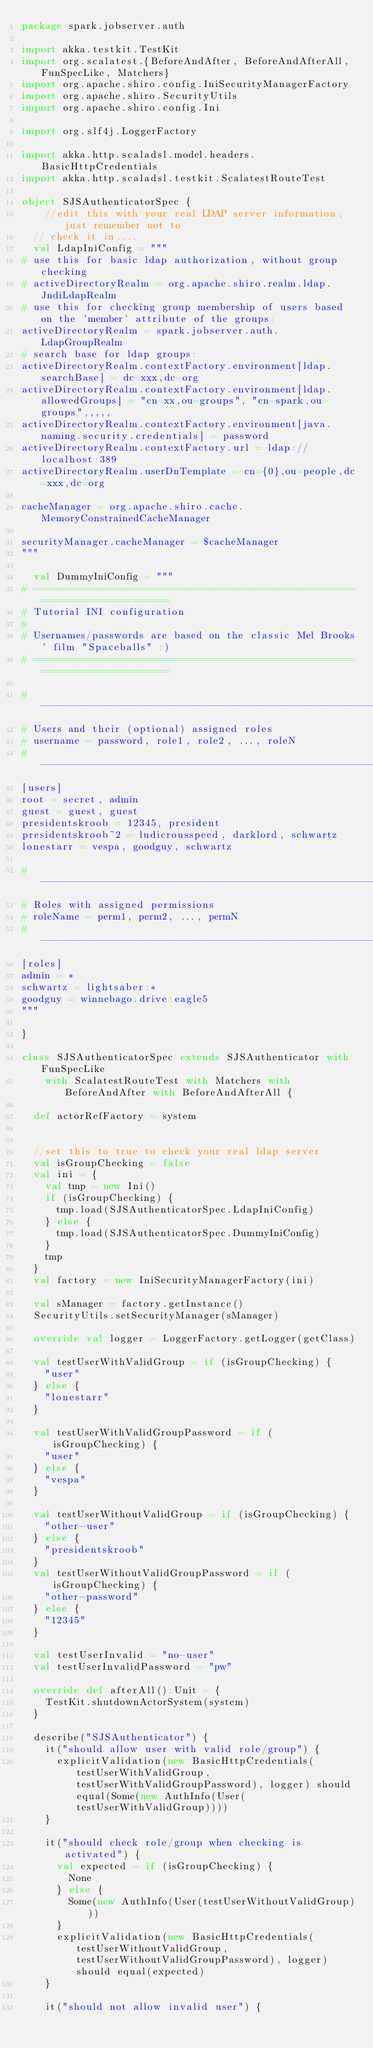<code> <loc_0><loc_0><loc_500><loc_500><_Scala_>package spark.jobserver.auth

import akka.testkit.TestKit
import org.scalatest.{BeforeAndAfter, BeforeAndAfterAll, FunSpecLike, Matchers}
import org.apache.shiro.config.IniSecurityManagerFactory
import org.apache.shiro.SecurityUtils
import org.apache.shiro.config.Ini

import org.slf4j.LoggerFactory

import akka.http.scaladsl.model.headers.BasicHttpCredentials
import akka.http.scaladsl.testkit.ScalatestRouteTest

object SJSAuthenticatorSpec {
    //edit this with your real LDAP server information, just remember not to 
  // check it in....
  val LdapIniConfig = """
# use this for basic ldap authorization, without group checking
# activeDirectoryRealm = org.apache.shiro.realm.ldap.JndiLdapRealm
# use this for checking group membership of users based on the 'member' attribute of the groups:
activeDirectoryRealm = spark.jobserver.auth.LdapGroupRealm
# search base for ldap groups:
activeDirectoryRealm.contextFactory.environment[ldap.searchBase] = dc=xxx,dc=org
activeDirectoryRealm.contextFactory.environment[ldap.allowedGroups] = "cn=xx,ou=groups", "cn=spark,ou=groups",,,,,
activeDirectoryRealm.contextFactory.environment[java.naming.security.credentials] = password
activeDirectoryRealm.contextFactory.url = ldap://localhost:389
activeDirectoryRealm.userDnTemplate = cn={0},ou=people,dc=xxx,dc=org

cacheManager = org.apache.shiro.cache.MemoryConstrainedCacheManager

securityManager.cacheManager = $cacheManager
"""

  val DummyIniConfig = """
# =============================================================================
# Tutorial INI configuration
#
# Usernames/passwords are based on the classic Mel Brooks' film "Spaceballs" :)
# =============================================================================

# -----------------------------------------------------------------------------
# Users and their (optional) assigned roles
# username = password, role1, role2, ..., roleN
# -----------------------------------------------------------------------------
[users]
root = secret, admin
guest = guest, guest
presidentskroob = 12345, president
presidentskroob~2 = ludicrousspeed, darklord, schwartz
lonestarr = vespa, goodguy, schwartz

# -----------------------------------------------------------------------------
# Roles with assigned permissions
# roleName = perm1, perm2, ..., permN
# -----------------------------------------------------------------------------
[roles]
admin = *
schwartz = lightsaber:*
goodguy = winnebago:drive:eagle5
"""

}

class SJSAuthenticatorSpec extends SJSAuthenticator with FunSpecLike
    with ScalatestRouteTest with Matchers with BeforeAndAfter with BeforeAndAfterAll {

  def actorRefFactory = system


  //set this to true to check your real ldap server
  val isGroupChecking = false
  val ini = {
    val tmp = new Ini()
    if (isGroupChecking) {
      tmp.load(SJSAuthenticatorSpec.LdapIniConfig)
    } else {
      tmp.load(SJSAuthenticatorSpec.DummyIniConfig)
    }
    tmp
  }
  val factory = new IniSecurityManagerFactory(ini)

  val sManager = factory.getInstance()
  SecurityUtils.setSecurityManager(sManager)

  override val logger = LoggerFactory.getLogger(getClass)

  val testUserWithValidGroup = if (isGroupChecking) {
    "user"
  } else {
    "lonestarr"
  }

  val testUserWithValidGroupPassword = if (isGroupChecking) {
    "user"
  } else {
    "vespa"
  }

  val testUserWithoutValidGroup = if (isGroupChecking) {
    "other-user"
  } else {
    "presidentskroob"
  }
  val testUserWithoutValidGroupPassword = if (isGroupChecking) {
    "other-password"
  } else {
    "12345"
  }

  val testUserInvalid = "no-user"
  val testUserInvalidPassword = "pw"

  override def afterAll():Unit = {
    TestKit.shutdownActorSystem(system)
  }

  describe("SJSAuthenticator") {
    it("should allow user with valid role/group") {
      explicitValidation(new BasicHttpCredentials(testUserWithValidGroup, testUserWithValidGroupPassword), logger) should equal(Some(new AuthInfo(User(testUserWithValidGroup))))
    }

    it("should check role/group when checking is activated") {
      val expected = if (isGroupChecking) {
        None
      } else {
        Some(new AuthInfo(User(testUserWithoutValidGroup)))
      }
      explicitValidation(new BasicHttpCredentials(testUserWithoutValidGroup, testUserWithoutValidGroupPassword), logger) should equal(expected)
    }

    it("should not allow invalid user") {</code> 